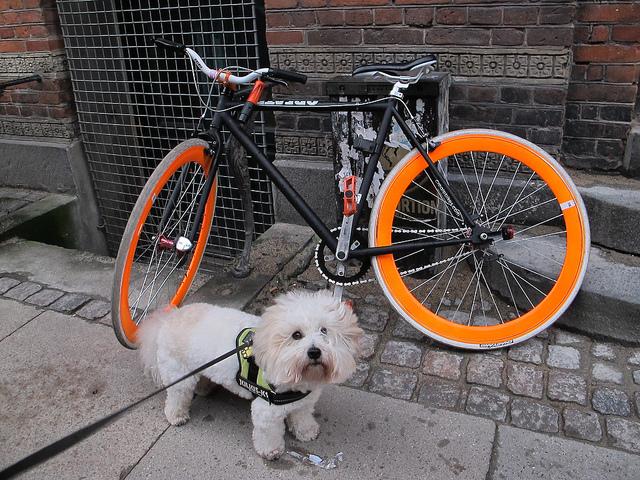Are there steps in the picture?
Concise answer only. Yes. What is the dog doing?
Write a very short answer. Standing. What color are the bike tires?
Short answer required. Orange. 